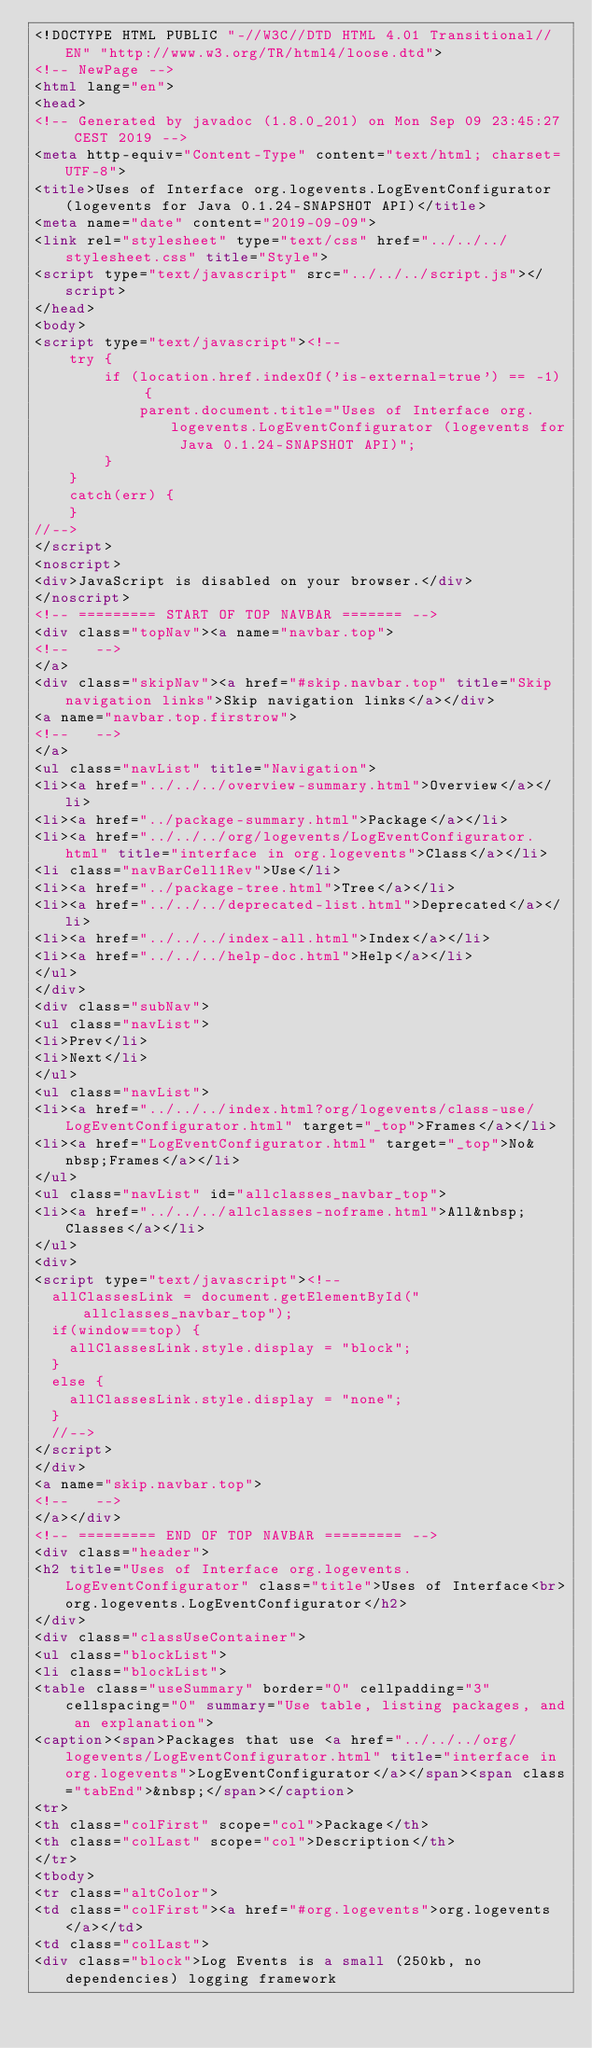Convert code to text. <code><loc_0><loc_0><loc_500><loc_500><_HTML_><!DOCTYPE HTML PUBLIC "-//W3C//DTD HTML 4.01 Transitional//EN" "http://www.w3.org/TR/html4/loose.dtd">
<!-- NewPage -->
<html lang="en">
<head>
<!-- Generated by javadoc (1.8.0_201) on Mon Sep 09 23:45:27 CEST 2019 -->
<meta http-equiv="Content-Type" content="text/html; charset=UTF-8">
<title>Uses of Interface org.logevents.LogEventConfigurator (logevents for Java 0.1.24-SNAPSHOT API)</title>
<meta name="date" content="2019-09-09">
<link rel="stylesheet" type="text/css" href="../../../stylesheet.css" title="Style">
<script type="text/javascript" src="../../../script.js"></script>
</head>
<body>
<script type="text/javascript"><!--
    try {
        if (location.href.indexOf('is-external=true') == -1) {
            parent.document.title="Uses of Interface org.logevents.LogEventConfigurator (logevents for Java 0.1.24-SNAPSHOT API)";
        }
    }
    catch(err) {
    }
//-->
</script>
<noscript>
<div>JavaScript is disabled on your browser.</div>
</noscript>
<!-- ========= START OF TOP NAVBAR ======= -->
<div class="topNav"><a name="navbar.top">
<!--   -->
</a>
<div class="skipNav"><a href="#skip.navbar.top" title="Skip navigation links">Skip navigation links</a></div>
<a name="navbar.top.firstrow">
<!--   -->
</a>
<ul class="navList" title="Navigation">
<li><a href="../../../overview-summary.html">Overview</a></li>
<li><a href="../package-summary.html">Package</a></li>
<li><a href="../../../org/logevents/LogEventConfigurator.html" title="interface in org.logevents">Class</a></li>
<li class="navBarCell1Rev">Use</li>
<li><a href="../package-tree.html">Tree</a></li>
<li><a href="../../../deprecated-list.html">Deprecated</a></li>
<li><a href="../../../index-all.html">Index</a></li>
<li><a href="../../../help-doc.html">Help</a></li>
</ul>
</div>
<div class="subNav">
<ul class="navList">
<li>Prev</li>
<li>Next</li>
</ul>
<ul class="navList">
<li><a href="../../../index.html?org/logevents/class-use/LogEventConfigurator.html" target="_top">Frames</a></li>
<li><a href="LogEventConfigurator.html" target="_top">No&nbsp;Frames</a></li>
</ul>
<ul class="navList" id="allclasses_navbar_top">
<li><a href="../../../allclasses-noframe.html">All&nbsp;Classes</a></li>
</ul>
<div>
<script type="text/javascript"><!--
  allClassesLink = document.getElementById("allclasses_navbar_top");
  if(window==top) {
    allClassesLink.style.display = "block";
  }
  else {
    allClassesLink.style.display = "none";
  }
  //-->
</script>
</div>
<a name="skip.navbar.top">
<!--   -->
</a></div>
<!-- ========= END OF TOP NAVBAR ========= -->
<div class="header">
<h2 title="Uses of Interface org.logevents.LogEventConfigurator" class="title">Uses of Interface<br>org.logevents.LogEventConfigurator</h2>
</div>
<div class="classUseContainer">
<ul class="blockList">
<li class="blockList">
<table class="useSummary" border="0" cellpadding="3" cellspacing="0" summary="Use table, listing packages, and an explanation">
<caption><span>Packages that use <a href="../../../org/logevents/LogEventConfigurator.html" title="interface in org.logevents">LogEventConfigurator</a></span><span class="tabEnd">&nbsp;</span></caption>
<tr>
<th class="colFirst" scope="col">Package</th>
<th class="colLast" scope="col">Description</th>
</tr>
<tbody>
<tr class="altColor">
<td class="colFirst"><a href="#org.logevents">org.logevents</a></td>
<td class="colLast">
<div class="block">Log Events is a small (250kb, no dependencies) logging framework</code> 